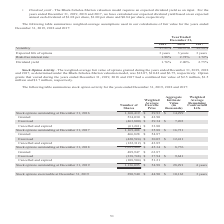From Mantech International's financial document, What were the weighted-average fair value of options granted during the years ended December 31, 2017, 2018, and 2019, respectively? The document contains multiple relevant values: $6.75, $10.42, $12.07. From the document: "nder the Black-Scholes-Merton valuation model, was $12.07, $10.42 and $6.75, respectively. Option grants that vested during the years ended December 3..." Also, What was the number of stock options that were outstanding at December 31, 2017? According to the financial document, 1,169,408. The relevant text states: "80 Stock options outstanding at December 31, 2017 1,169,408 $ 35.88 $ 16,731 Granted 466,828 $ 54.87 Exercised (420,524) $ 30.05 $ 12,411 Cancelled and expired..." Also, What was the weighted average remaining contractual life of the stock options outstanding as of December 31, 2019? According to the financial document, 4 years. The relevant text states: "g at December 31, 2019 1,136,095 $ 54.98 $ 28,291 4 years..." Also, can you calculate: What is the total value of stock options outstanding on December 31, 2018? Based on the calculation: 1,093,400*$45.34 , the result is 49574756. This is based on the information: "ions outstanding at December 31, 2018 1,093,400 $ 45.34 $ 8,776 Granted 489,947 $ 63.87 Exercised (338,748) $ 37.94 $ 9,641 Cancelled and expired (108,504) 85 Stock options outstanding at December 31,..." The key data points involved are: 1,093,400, 45.34. Also, can you calculate: What is the total price of stock options exercised or canceled and expired during the period between December 31, 2018, and 2019? Based on the calculation: (338,748*37.94)+(108,504*51.21), the result is 18408588.96. This is based on the information: "45.34 $ 8,776 Granted 489,947 $ 63.87 Exercised (338,748) $ 37.94 $ 9,641 Cancelled and expired (108,504) $ 51.21 Stock options outstanding at December 31, (338,748) $ 37.94 $ 9,641 Cancelled and expi..." The key data points involved are: 108,504, 338,748, 37.94. Also, can you calculate: What is the ratio of stock options exercisable to outstanding on December 31, 2019? Based on the calculation: 290,540/1,136,095, the result is 0.26. This is based on the information: "21 Stock options outstanding at December 31, 2019 1,136,095 $ 54.98 $ 28,291 4 years Stock options exercisable at December 31, 2019 290,540 $ 44.90 $ 10,163 3 years..." The key data points involved are: 1,136,095, 290,540. 